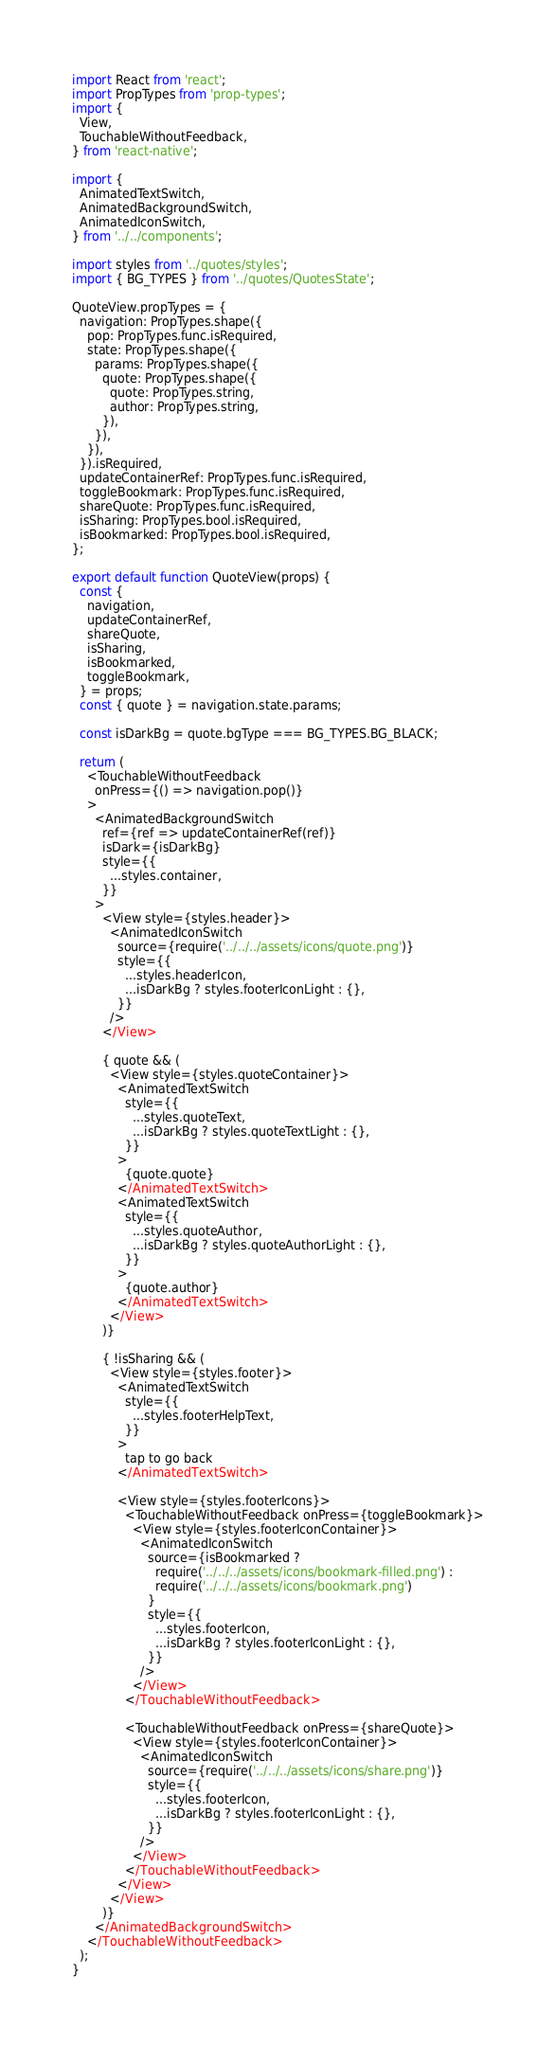<code> <loc_0><loc_0><loc_500><loc_500><_JavaScript_>import React from 'react';
import PropTypes from 'prop-types';
import {
  View,
  TouchableWithoutFeedback,
} from 'react-native';

import {
  AnimatedTextSwitch,
  AnimatedBackgroundSwitch,
  AnimatedIconSwitch,
} from '../../components';

import styles from '../quotes/styles';
import { BG_TYPES } from '../quotes/QuotesState';

QuoteView.propTypes = {
  navigation: PropTypes.shape({
    pop: PropTypes.func.isRequired,
    state: PropTypes.shape({
      params: PropTypes.shape({
        quote: PropTypes.shape({
          quote: PropTypes.string,
          author: PropTypes.string,
        }),
      }),
    }),
  }).isRequired,
  updateContainerRef: PropTypes.func.isRequired,
  toggleBookmark: PropTypes.func.isRequired,
  shareQuote: PropTypes.func.isRequired,
  isSharing: PropTypes.bool.isRequired,
  isBookmarked: PropTypes.bool.isRequired,
};

export default function QuoteView(props) {
  const {
    navigation,
    updateContainerRef,
    shareQuote,
    isSharing,
    isBookmarked,
    toggleBookmark,
  } = props;
  const { quote } = navigation.state.params;

  const isDarkBg = quote.bgType === BG_TYPES.BG_BLACK;

  return (
    <TouchableWithoutFeedback
      onPress={() => navigation.pop()}
    >
      <AnimatedBackgroundSwitch
        ref={ref => updateContainerRef(ref)}
        isDark={isDarkBg}
        style={{
          ...styles.container,
        }}
      >
        <View style={styles.header}>
          <AnimatedIconSwitch
            source={require('../../../assets/icons/quote.png')}
            style={{
              ...styles.headerIcon,
              ...isDarkBg ? styles.footerIconLight : {},
            }}
          />
        </View>

        { quote && (
          <View style={styles.quoteContainer}>
            <AnimatedTextSwitch
              style={{
                ...styles.quoteText,
                ...isDarkBg ? styles.quoteTextLight : {},
              }}
            >
              {quote.quote}
            </AnimatedTextSwitch>
            <AnimatedTextSwitch
              style={{
                ...styles.quoteAuthor,
                ...isDarkBg ? styles.quoteAuthorLight : {},
              }}
            >
              {quote.author}
            </AnimatedTextSwitch>
          </View>
        )}

        { !isSharing && (
          <View style={styles.footer}>
            <AnimatedTextSwitch
              style={{
                ...styles.footerHelpText,
              }}
            >
              tap to go back
            </AnimatedTextSwitch>

            <View style={styles.footerIcons}>
              <TouchableWithoutFeedback onPress={toggleBookmark}>
                <View style={styles.footerIconContainer}>
                  <AnimatedIconSwitch
                    source={isBookmarked ?
                      require('../../../assets/icons/bookmark-filled.png') :
                      require('../../../assets/icons/bookmark.png')
                    }
                    style={{
                      ...styles.footerIcon,
                      ...isDarkBg ? styles.footerIconLight : {},
                    }}
                  />
                </View>
              </TouchableWithoutFeedback>

              <TouchableWithoutFeedback onPress={shareQuote}>
                <View style={styles.footerIconContainer}>
                  <AnimatedIconSwitch
                    source={require('../../../assets/icons/share.png')}
                    style={{
                      ...styles.footerIcon,
                      ...isDarkBg ? styles.footerIconLight : {},
                    }}
                  />
                </View>
              </TouchableWithoutFeedback>
            </View>
          </View>
        )}
      </AnimatedBackgroundSwitch>
    </TouchableWithoutFeedback>
  );
}
</code> 